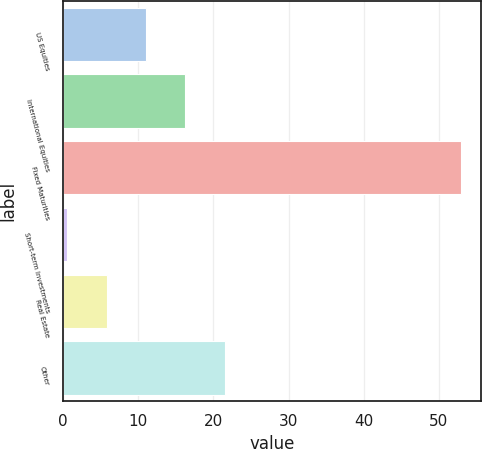Convert chart. <chart><loc_0><loc_0><loc_500><loc_500><bar_chart><fcel>US Equities<fcel>International Equities<fcel>Fixed Maturities<fcel>Short-term Investments<fcel>Real Estate<fcel>Other<nl><fcel>11.01<fcel>16.26<fcel>53<fcel>0.51<fcel>5.76<fcel>21.51<nl></chart> 